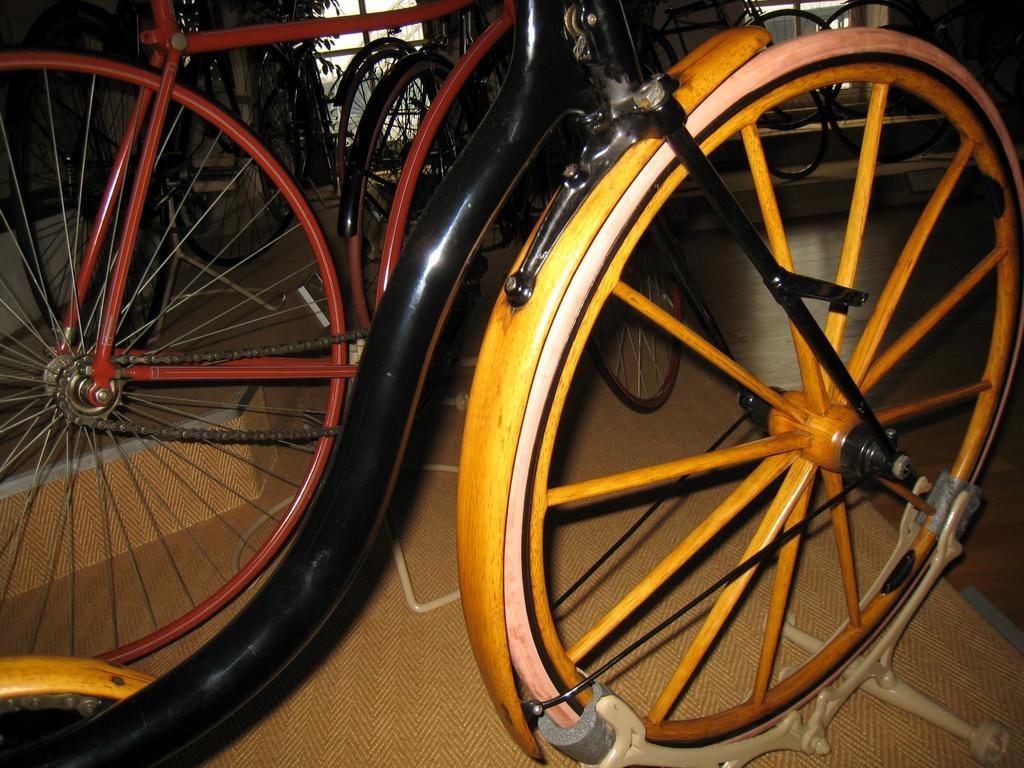How would you summarize this image in a sentence or two? In this picture, we see bicycles in red, yellow and black color. In the background, we see trees and buildings. This picture might be clicked in the bicycle garage. 